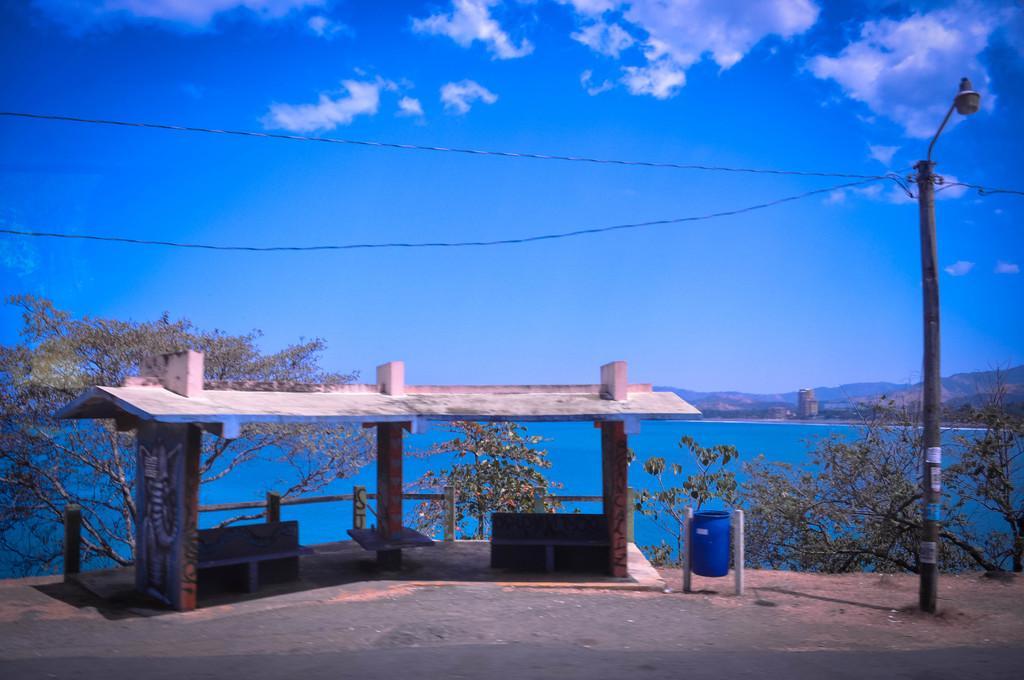How would you summarize this image in a sentence or two? In this image we can see a shed and there are few benches and to the side, we can see a tub which looks like a dustbin. There are some trees and we can see the water and there is a street light on the right side of the image. In the background, we can see the mountains and at the top we can see the sky. 